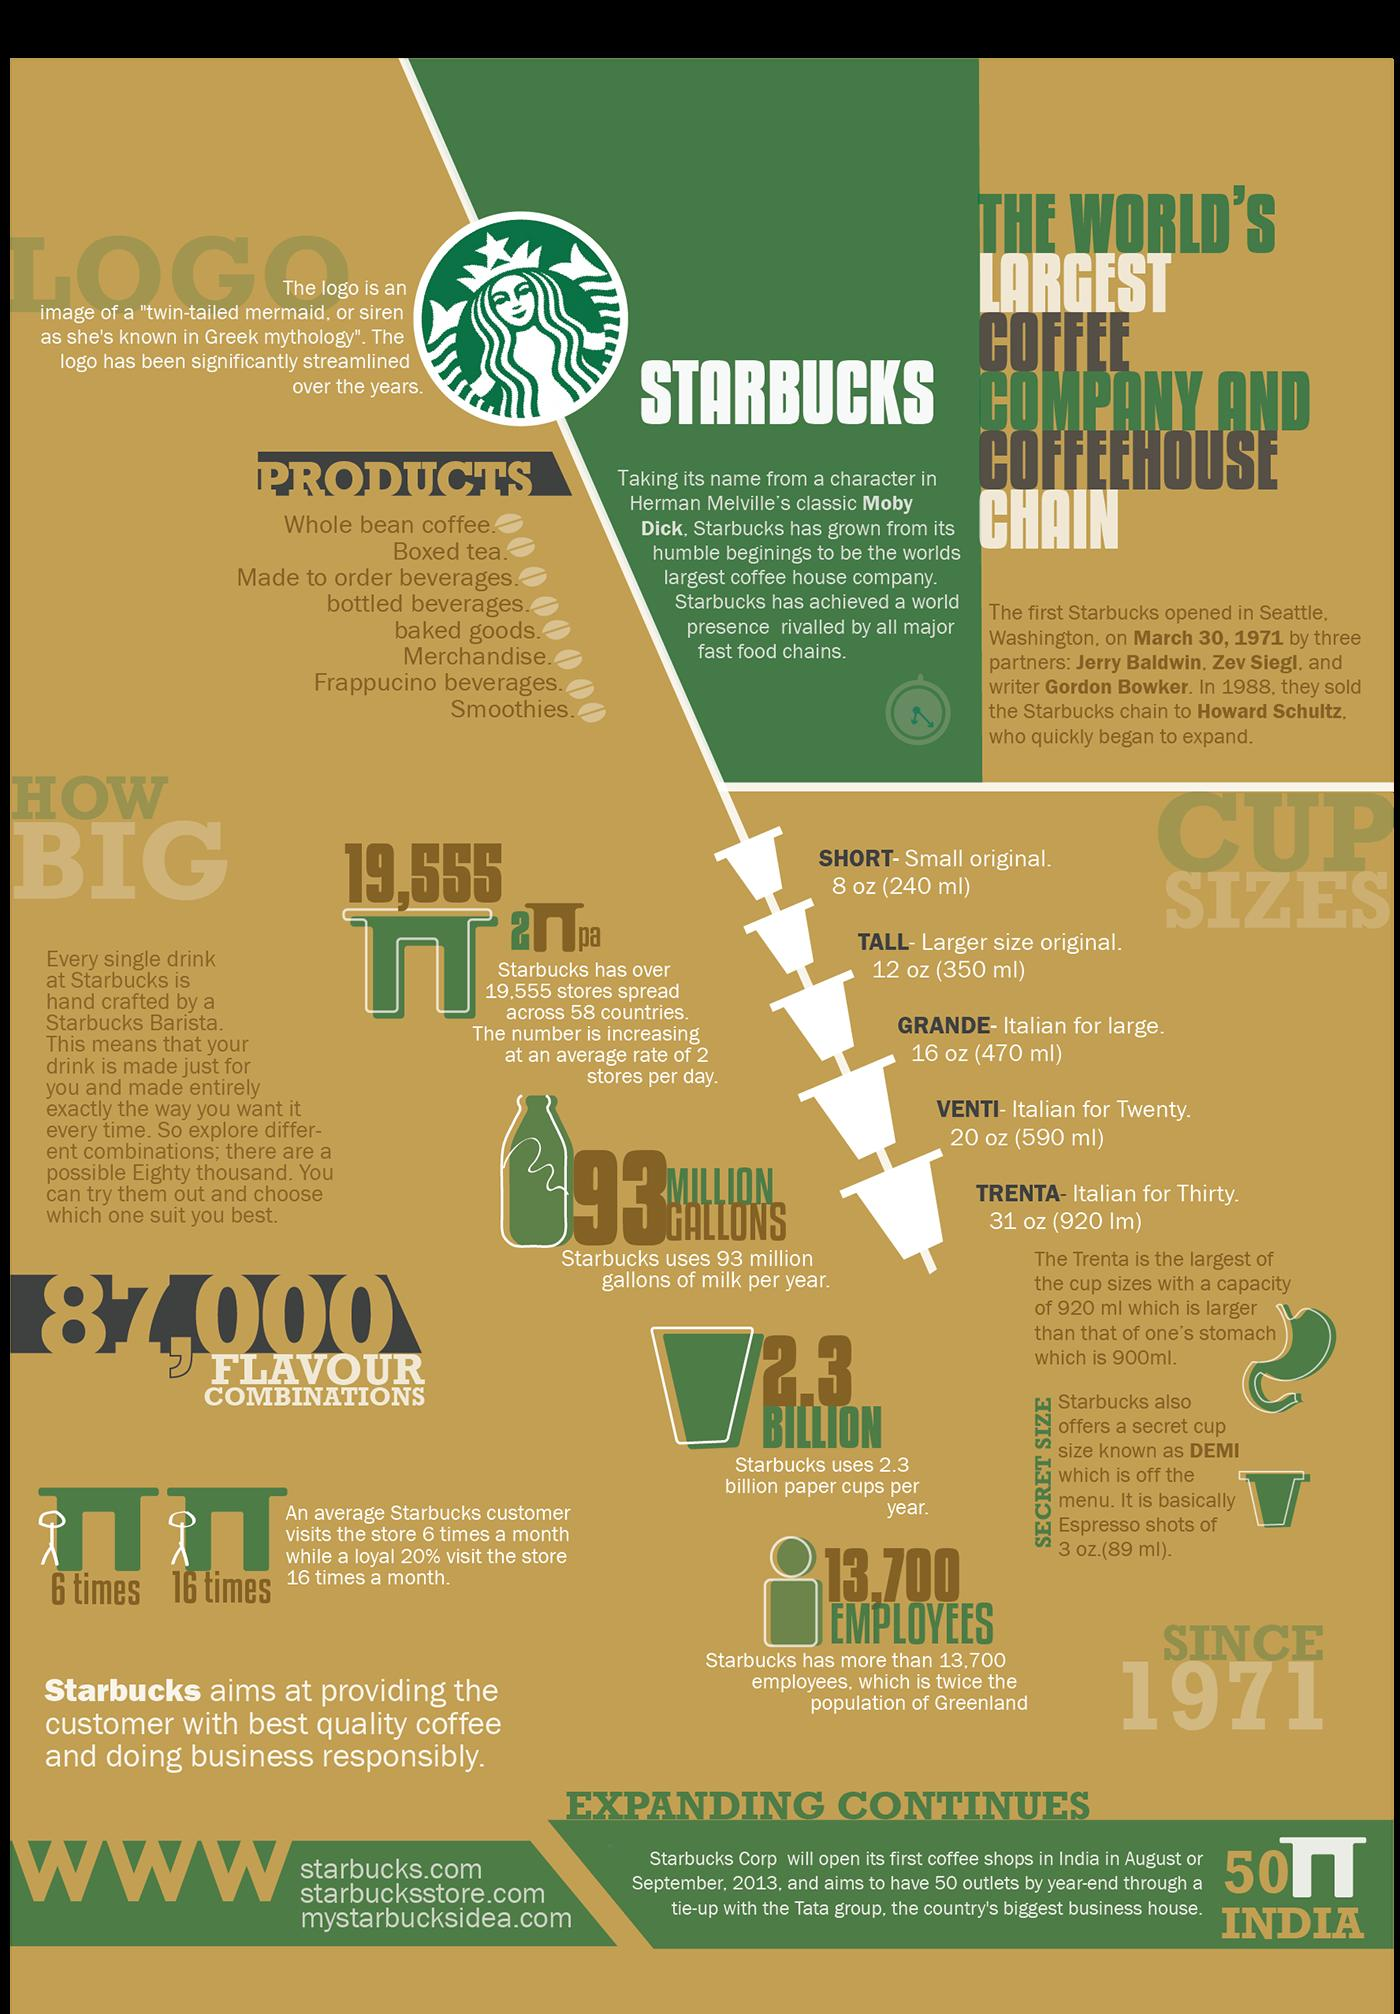Draw attention to some important aspects in this diagram. The average customer makes 10 store visits per month, while a loyal customer makes 15 store visits per month, on average. The brand being discussed is Starbucks. Eight product types are mentioned. The number of stores being added per day is currently at 2.. The term "venti" refers to a specific size in the cups system used to measure the capacity of liquid containers. A cup size of 590 milliliters is called "venti. 